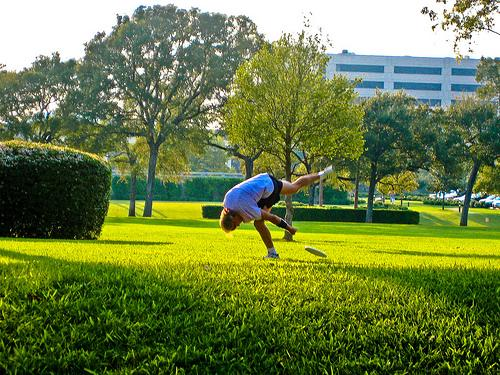Describe the natural elements present in the image. The image features green grass, trees, and a hedge, as well as a shrub in the middle of the field. Provide a description of the man's position and body language while playing with the frisbee. The person is bending forward with his left feet raised, trying to catch the frisbee while it is in the air. What objects can be found behind the trees in the image? A building and cars parked in a parking lot can be found behind the trees. What is the state of the grass in the image, and are there any other plants? The grass is cut short, and there is a green shrub hedge along the field. What does the man wear, and what is the color of the frisbee? The man wears a white shirt, black shorts, and white sneakers; the frisbee is white. Comment on the size and shape of the building's windows. The building's windows are long and narrow, with a bounding box size of 113x113. Identify the central activity taking place in the image. A person is playing with a frisbee in an open field of grass. Mention any distinctive features of the man's attire. The man is wearing a wristband and white socks. Please provide a brief description of the setting in the image. The setting is a grassy field with trees, a shrub, shadows, and a building in the background with cars parked in front of it. 